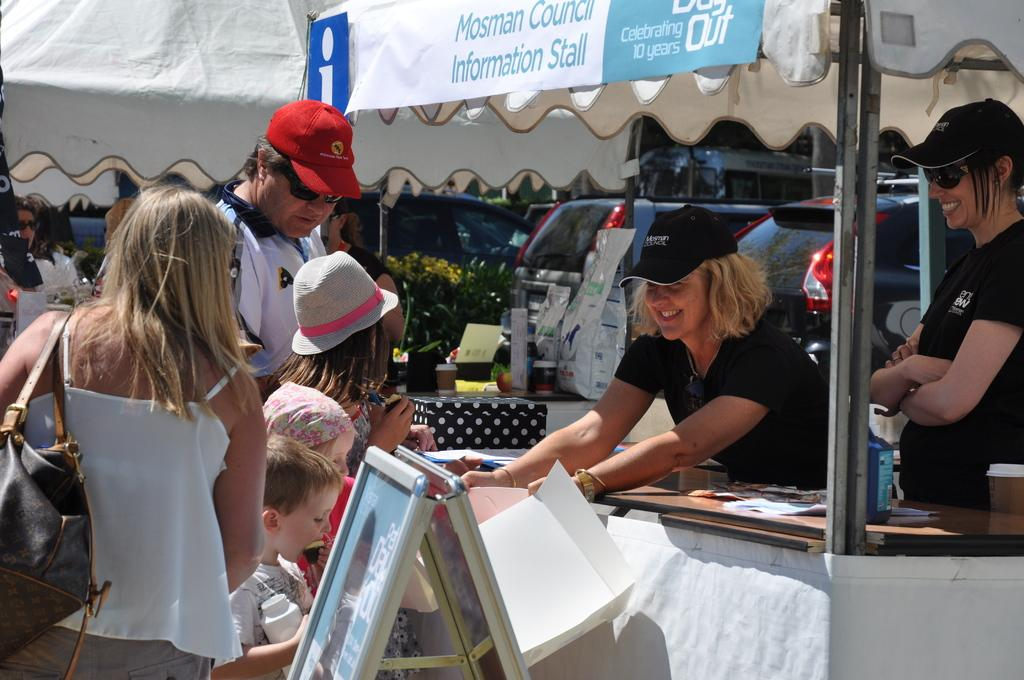How many people are in the image? There is a group of people in the image, but the exact number cannot be determined from the provided facts. What type of temporary shelters can be seen in the image? There are tents in the image. What else is visible in the image besides the people and tents? There are objects in the image. What can be seen in the background of the image? There are vehicles and plants in the background of the image. Can you see a boat in the image? No, there is no boat present in the image. 